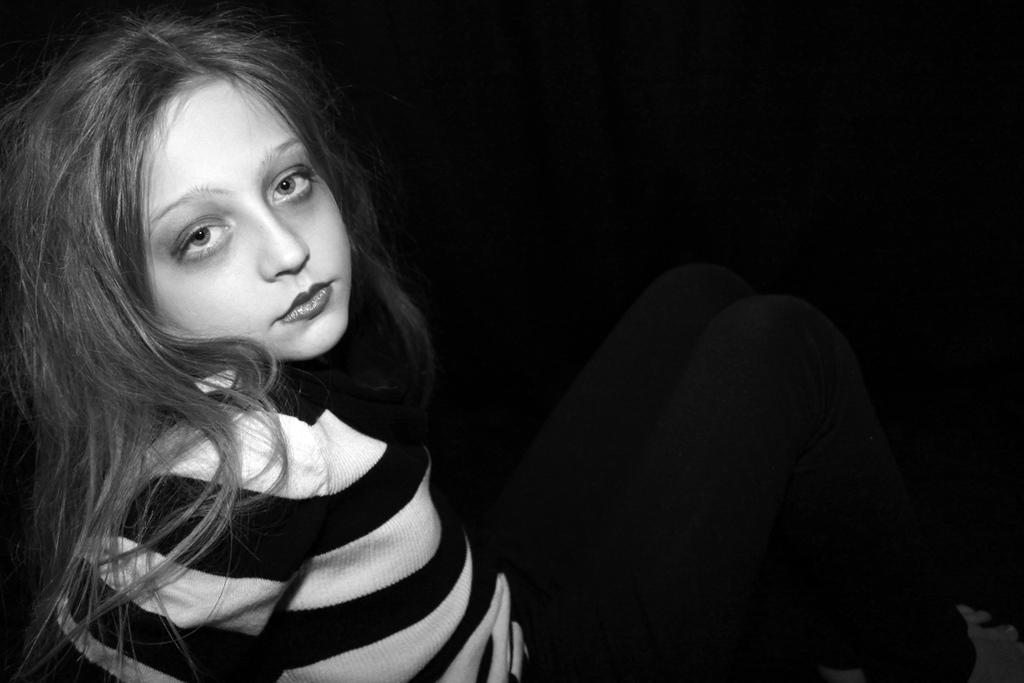Can you describe this image briefly? The picture consists of a girl. The girl is wearing a black and white striped t-shirt. The background is black. 